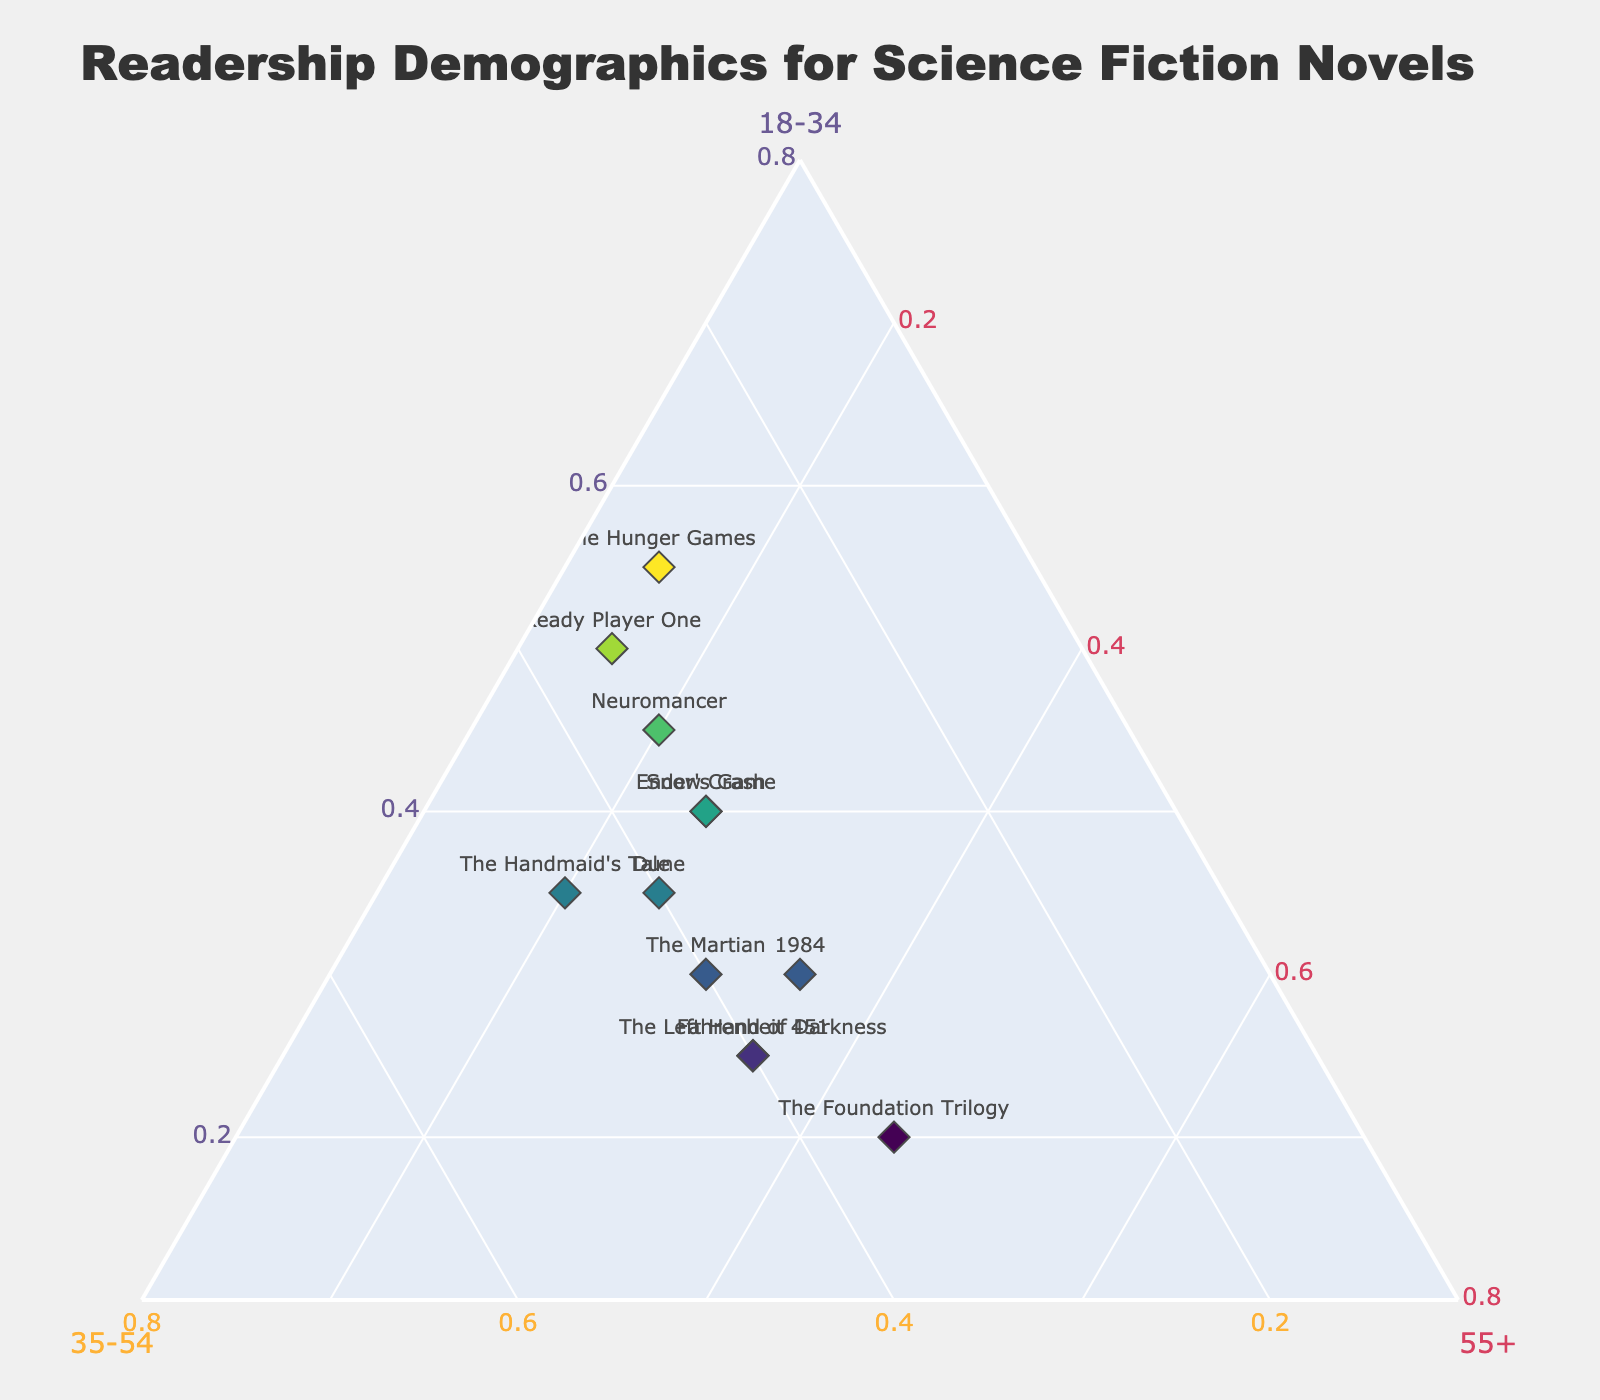What is the title of the plot? The title is located at the top of the plot and is typically displayed in a larger and bolder font than other text elements.
Answer: Readership Demographics for Science Fiction Novels How many books are represented in the ternary plot? Each book is represented by a marker on the plot. Count the number of unique markers.
Answer: 12 Which age group has the highest normalized value for 'The Hunger Games'? Locate 'The Hunger Games' on the plot and check the position of its marker relative to the '18-34' axis. The marker is closest to the '18-34' axis, indicating the highest value for this group.
Answer: 18-34 Which book has the most balanced readership across all three age groups? Check the positions of the markers relative to the center of the plot. 'The Martian' has a nearly equal distribution among all three age groups, indicating balance.
Answer: The Martian Which book has the highest proportion of readers in the 55+ age group? Find the marker closest to the '55+' axis of the ternary plot. This indicates the highest value for that age group.
Answer: The Foundation Trilogy What percentage of 'Ready Player One' readers falls in the 18-34 age group? Locate 'Ready Player One' and check its position on the plot. The normalized value closest to the '18-34' axis provides the percentage, which was normalized to 50%.
Answer: 50% Among Neuromancer, Dune, and Ender's Game, which has the highest readership among the 35-54 age group? Compare the positions of these books relating to the '35-54' axis. 'Dune' and 'The Handmaid's Tale' have the marker closest to '35-54' axis. Check the normalized data for precision.
Answer: The Handmaid's Tale What is the total number of books having at least 40% of their readership in the 18-34 age group? Count the markers positioned closer to the '18-34' axis with at least 40% normalized value. The books are 'Neuromancer,' 'Ready Player One,' 'The Hunger Games,' 'Ender's Game,' and 'Snow Crash.'
Answer: 5 Which book has a readership mostly concentrated in the 35-54 age group? The marker for 'The Handmaid's Tale' is closest to the '35-54' axis, indicating a concentration in this age group.
Answer: The Handmaid's Tale Compare the readership of '1984' and 'Fahrenheit 451' in the 55+ age group. Which has a higher proportion? Check the positions of both markers relative to the '55+' axis. '1984' and 'Fahrenheit 451' are equally distanced from the 55+ axis so the normalized values will show the true age group value.
Answer: Equal 